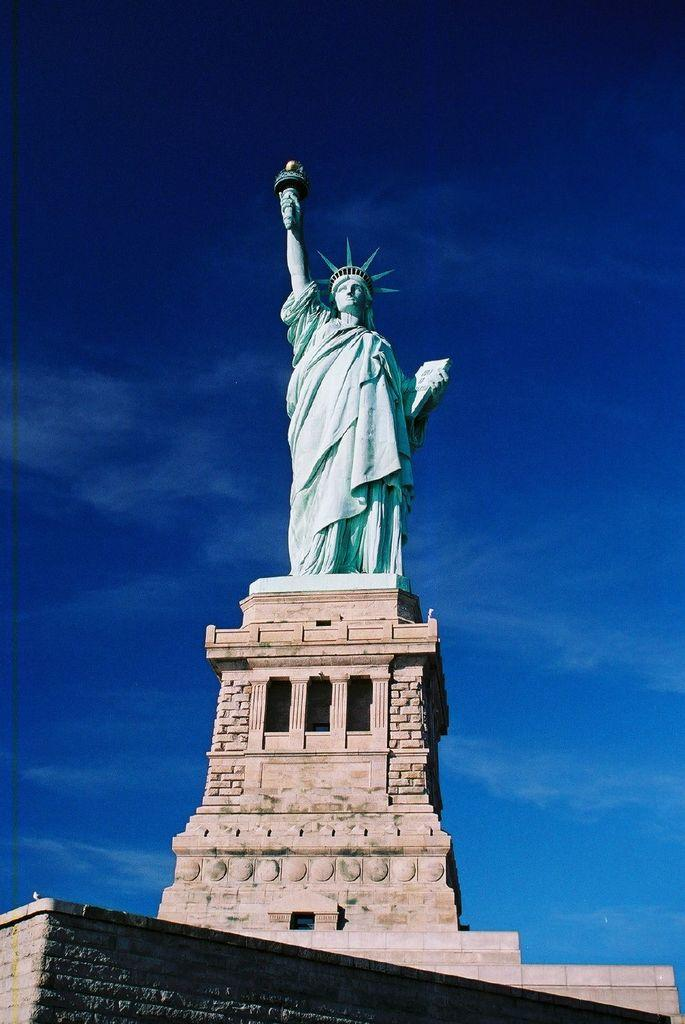What is the main subject of the image? There is a statue of liberty in the image. How is the statue of liberty positioned in the image? The statue of liberty is on a block. What can be seen in the sky in the image? There are clouds in the sky in the image. Where is the meeting taking place in the image? There is no meeting present in the image; it features a statue of liberty on a block with clouds in the sky. What type of badge is the statue wearing in the image? The statue of liberty is not wearing a badge in the image; it is a statue and does not have clothing or accessories. 